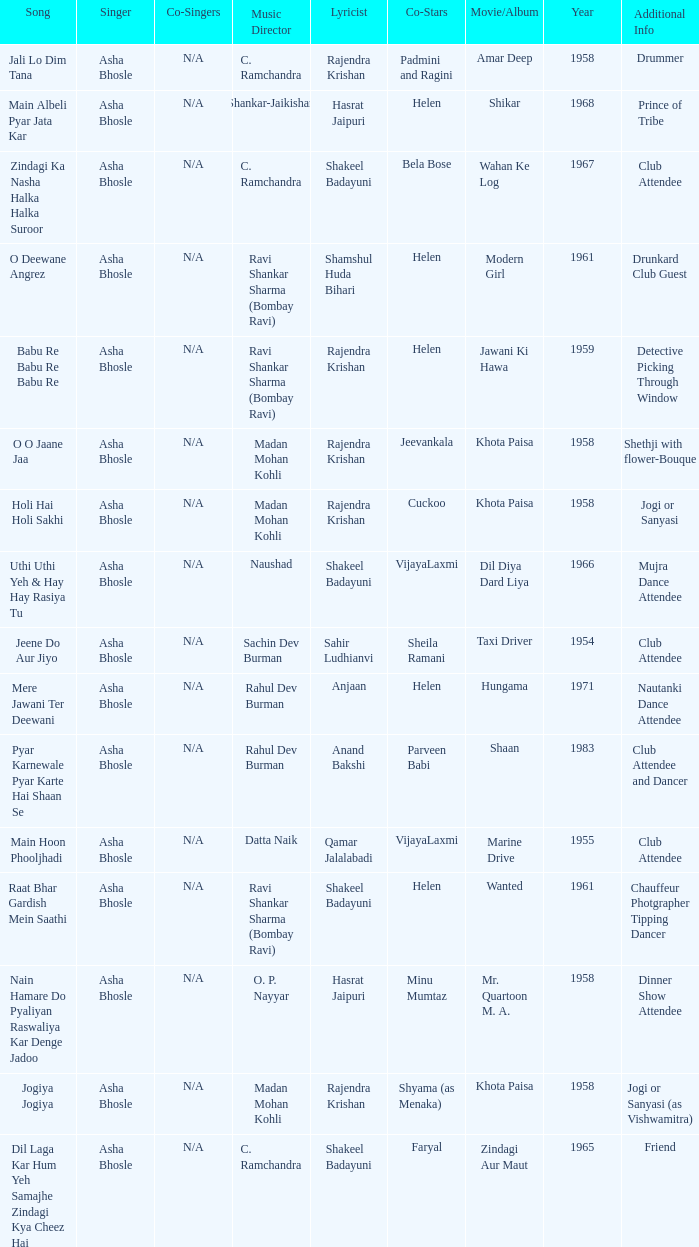Who wrote the lyrics when Jeevankala co-starred? Rajendra Krishan. 